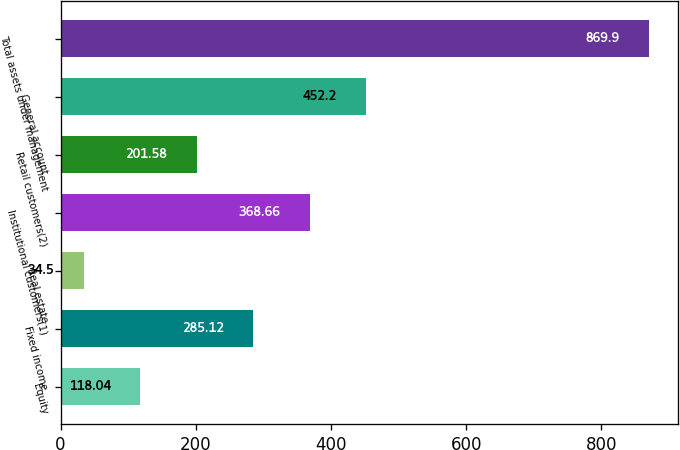Convert chart. <chart><loc_0><loc_0><loc_500><loc_500><bar_chart><fcel>Equity<fcel>Fixed income<fcel>Real estate<fcel>Institutional customers(1)<fcel>Retail customers(2)<fcel>General account<fcel>Total assets under management<nl><fcel>118.04<fcel>285.12<fcel>34.5<fcel>368.66<fcel>201.58<fcel>452.2<fcel>869.9<nl></chart> 